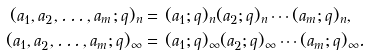<formula> <loc_0><loc_0><loc_500><loc_500>( a _ { 1 } , a _ { 2 } , \dots , a _ { m } ; q ) _ { n } = & \ ( a _ { 1 } ; q ) _ { n } ( a _ { 2 } ; q ) _ { n } \cdots ( a _ { m } ; q ) _ { n } , \\ ( a _ { 1 } , a _ { 2 } , \dots , a _ { m } ; q ) _ { \infty } = & \ ( a _ { 1 } ; q ) _ { \infty } ( a _ { 2 } ; q ) _ { \infty } \cdots ( a _ { m } ; q ) _ { \infty } .</formula> 